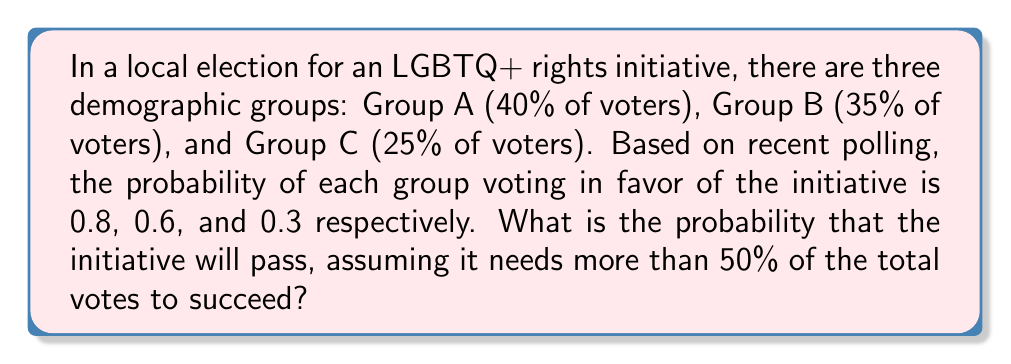Can you solve this math problem? Let's approach this step-by-step:

1) First, we need to calculate the probability of getting a favorable vote from each group:

   Group A: $0.40 \times 0.8 = 0.32$
   Group B: $0.35 \times 0.6 = 0.21$
   Group C: $0.25 \times 0.3 = 0.075$

2) The total probability of a favorable vote is the sum of these:

   $P(\text{favorable vote}) = 0.32 + 0.21 + 0.075 = 0.605$

3) This means that the expected percentage of favorable votes is 60.5%, which is already above the 50% threshold needed to pass.

4) However, to be more precise, we need to consider the probability distribution of votes. This follows a binomial distribution.

5) Let $X$ be the number of favorable votes out of $n$ total votes. Then:

   $X \sim B(n, 0.605)$

6) The initiative passes if $X > 0.5n$

7) For large $n$, we can approximate this using the normal distribution:

   $X \approx N(np, np(1-p))$

   Where $p = 0.605$

8) Standardizing, we get:

   $Z = \frac{X - np}{\sqrt{np(1-p)}} \approx N(0,1)$

9) We want $P(X > 0.5n)$, which is equivalent to:

   $P(Z > \frac{0.5n - 0.605n}{\sqrt{0.605n(1-0.605)}})$

   $= P(Z > \frac{-0.105n}{\sqrt{0.23897n}})$

   $= P(Z > -0.2149\sqrt{n})$

10) As $n$ becomes large, this probability approaches 1.

Therefore, for any reasonably large number of voters, the probability of the initiative passing is very close to 1.
Answer: $\approx 1$ (for large $n$) 